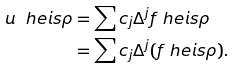<formula> <loc_0><loc_0><loc_500><loc_500>u \ h e i s \rho & = \sum c _ { j } \Delta ^ { j } f \ h e i s \rho \\ & = \sum c _ { j } \Delta ^ { j } ( f \ h e i s \rho ) .</formula> 